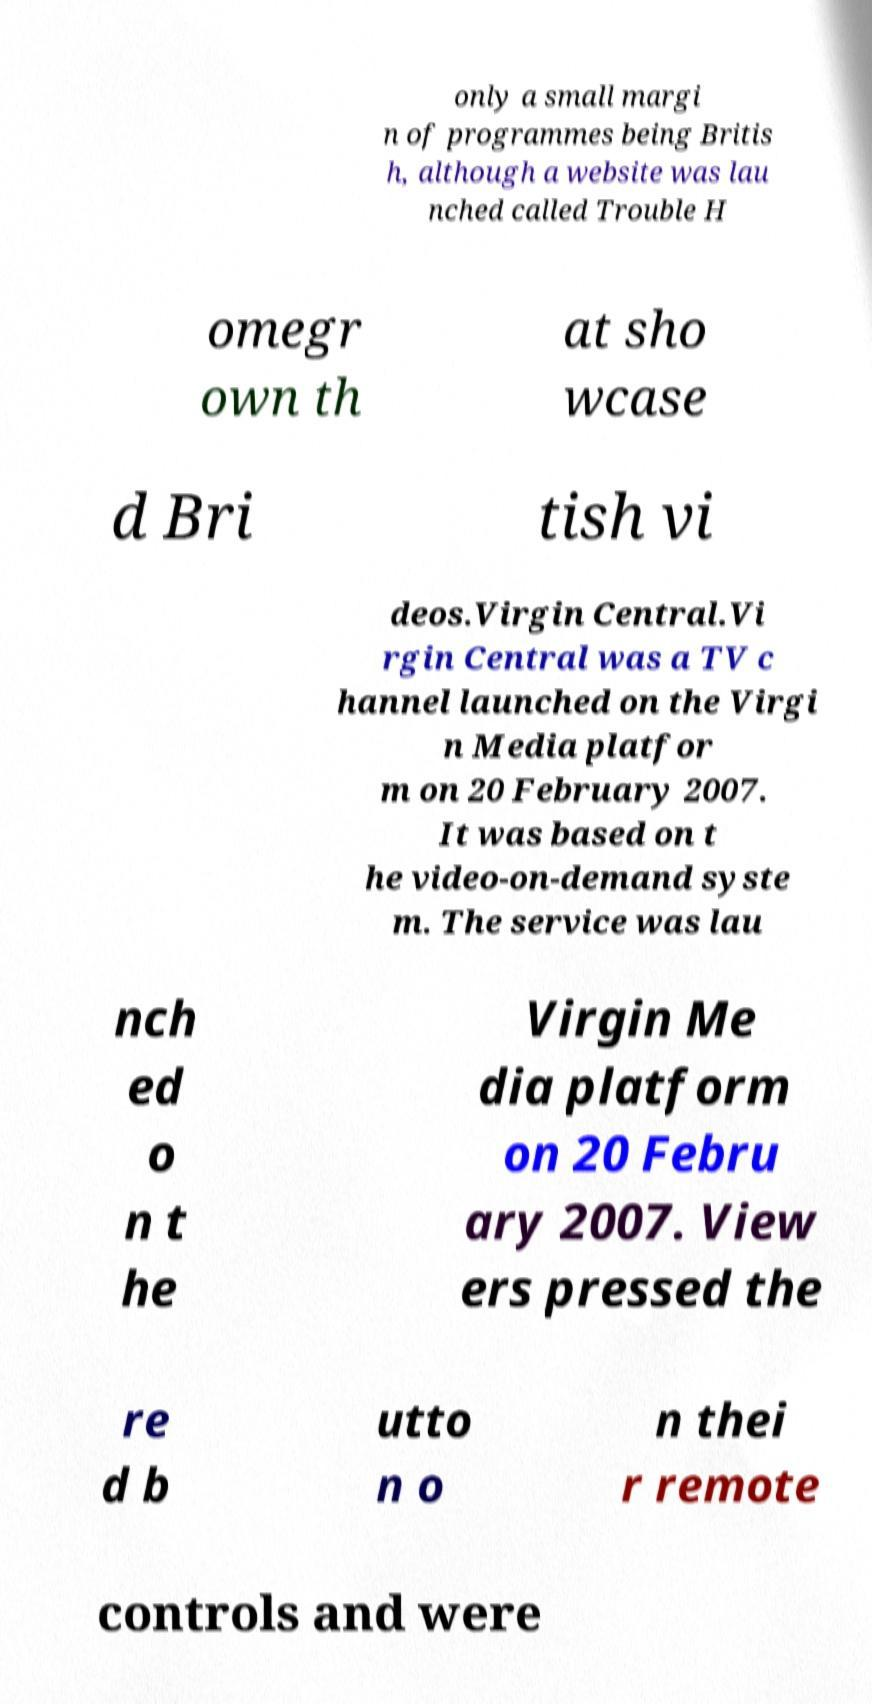I need the written content from this picture converted into text. Can you do that? only a small margi n of programmes being Britis h, although a website was lau nched called Trouble H omegr own th at sho wcase d Bri tish vi deos.Virgin Central.Vi rgin Central was a TV c hannel launched on the Virgi n Media platfor m on 20 February 2007. It was based on t he video-on-demand syste m. The service was lau nch ed o n t he Virgin Me dia platform on 20 Febru ary 2007. View ers pressed the re d b utto n o n thei r remote controls and were 